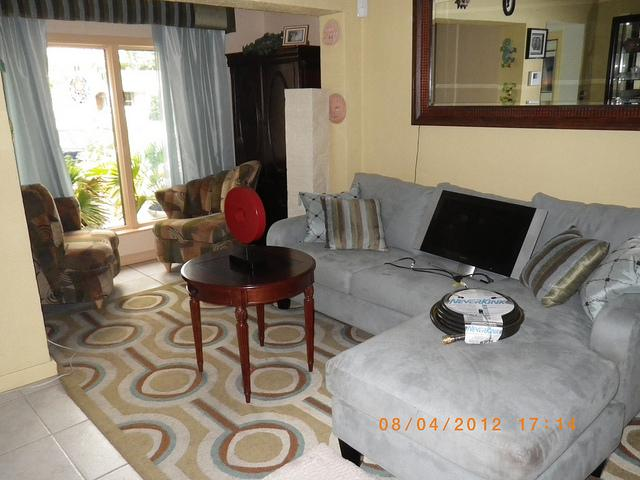What is on the couch? Please explain your reasoning. hose. There is a brand new black water hose on the couch still in the packaging. 